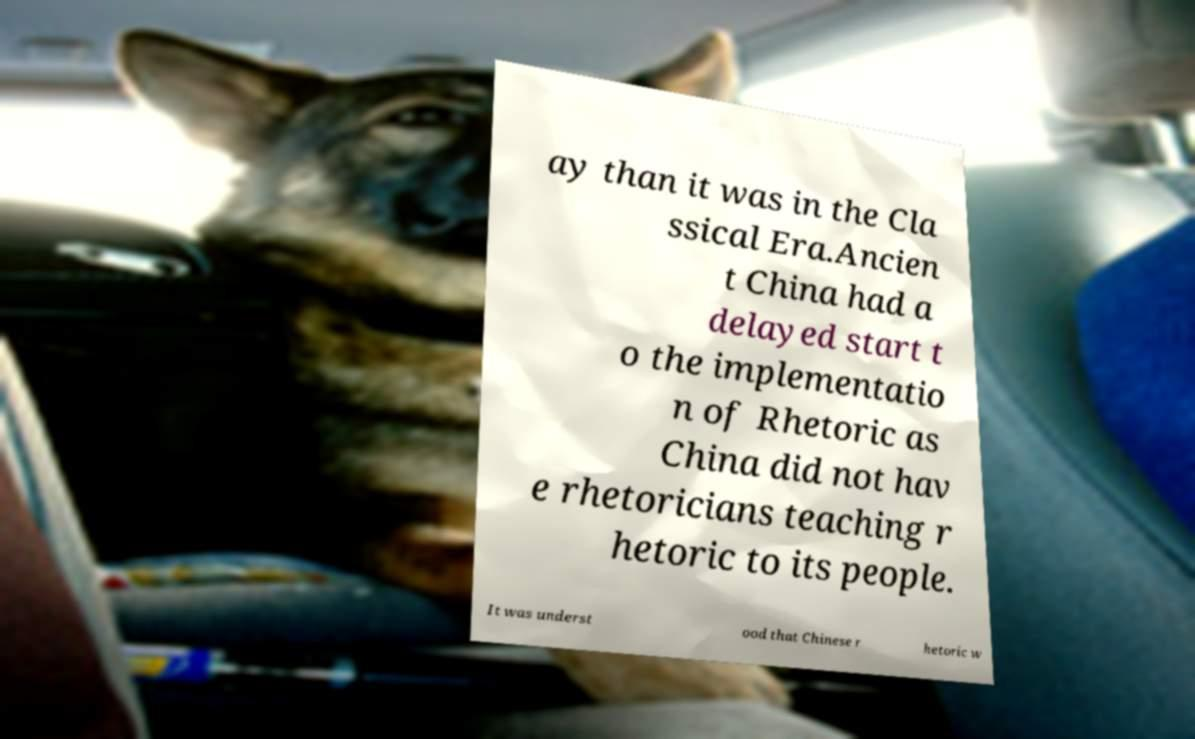I need the written content from this picture converted into text. Can you do that? ay than it was in the Cla ssical Era.Ancien t China had a delayed start t o the implementatio n of Rhetoric as China did not hav e rhetoricians teaching r hetoric to its people. It was underst ood that Chinese r hetoric w 